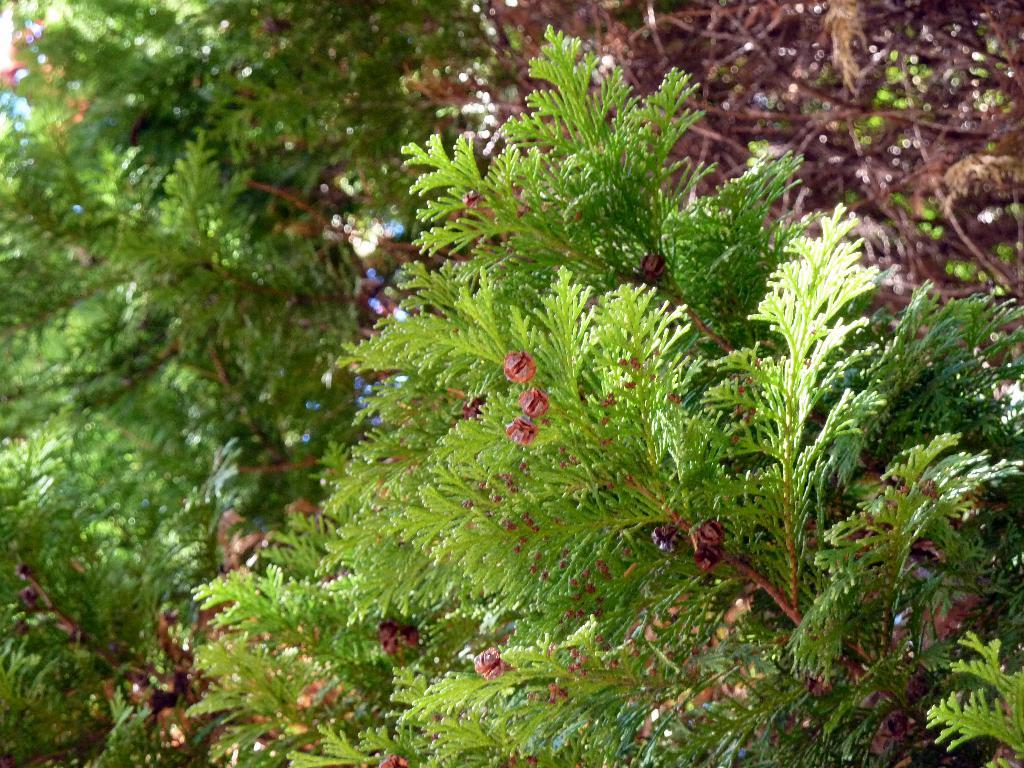What is the main subject in the image? There is a group of trees in the image. What type of wheel can be seen attached to the trees in the image? There is no wheel present in the image; it features a group of trees. How many pumpkins are visible hanging from the trees in the image? There are no pumpkins present in the image, as it only features a group of trees. 